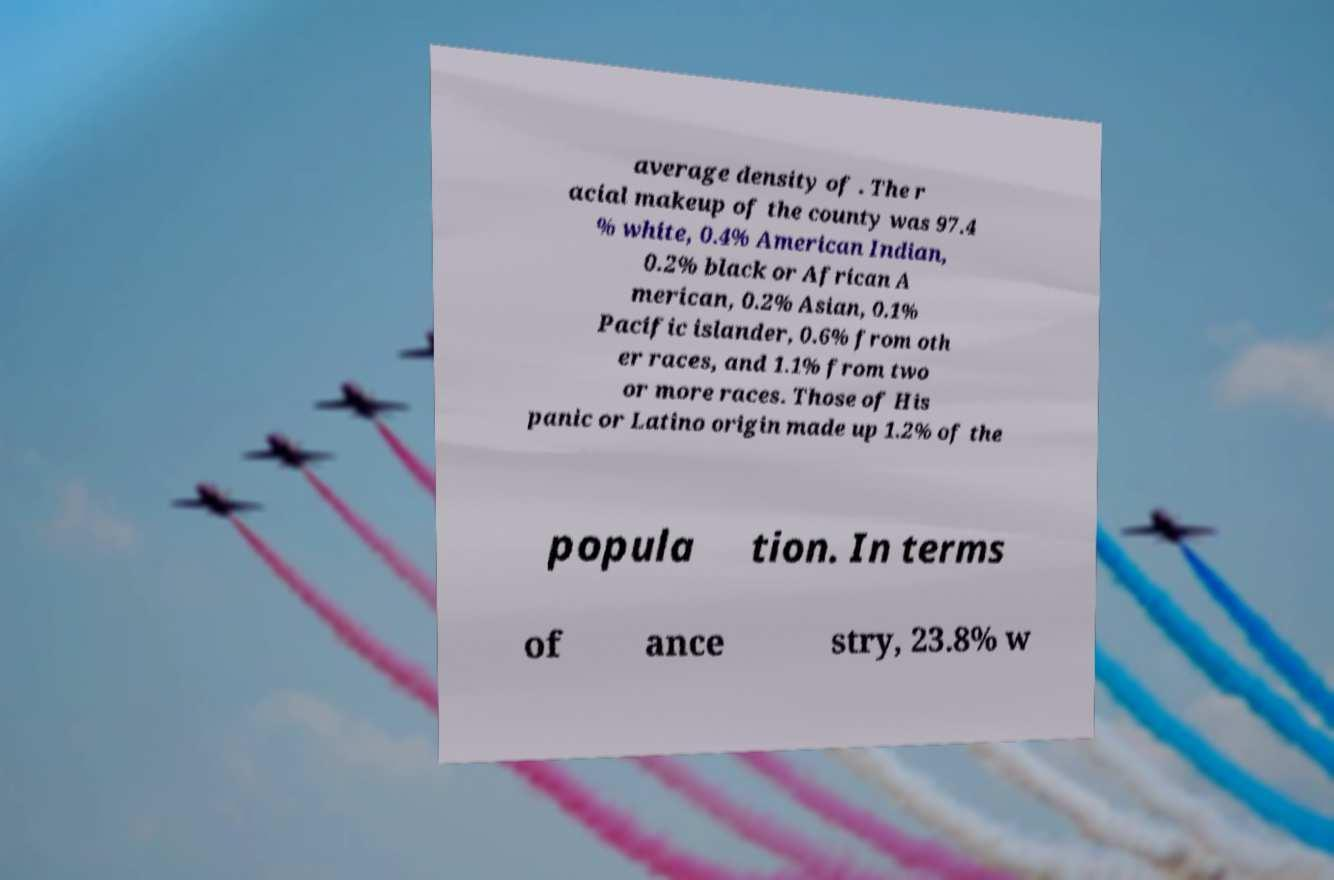Could you assist in decoding the text presented in this image and type it out clearly? average density of . The r acial makeup of the county was 97.4 % white, 0.4% American Indian, 0.2% black or African A merican, 0.2% Asian, 0.1% Pacific islander, 0.6% from oth er races, and 1.1% from two or more races. Those of His panic or Latino origin made up 1.2% of the popula tion. In terms of ance stry, 23.8% w 